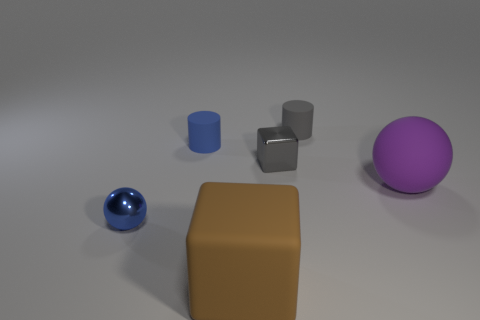Add 1 small brown metal objects. How many objects exist? 7 Subtract all blocks. How many objects are left? 4 Subtract all small gray cubes. Subtract all tiny yellow blocks. How many objects are left? 5 Add 6 blue things. How many blue things are left? 8 Add 1 gray blocks. How many gray blocks exist? 2 Subtract 0 green cubes. How many objects are left? 6 